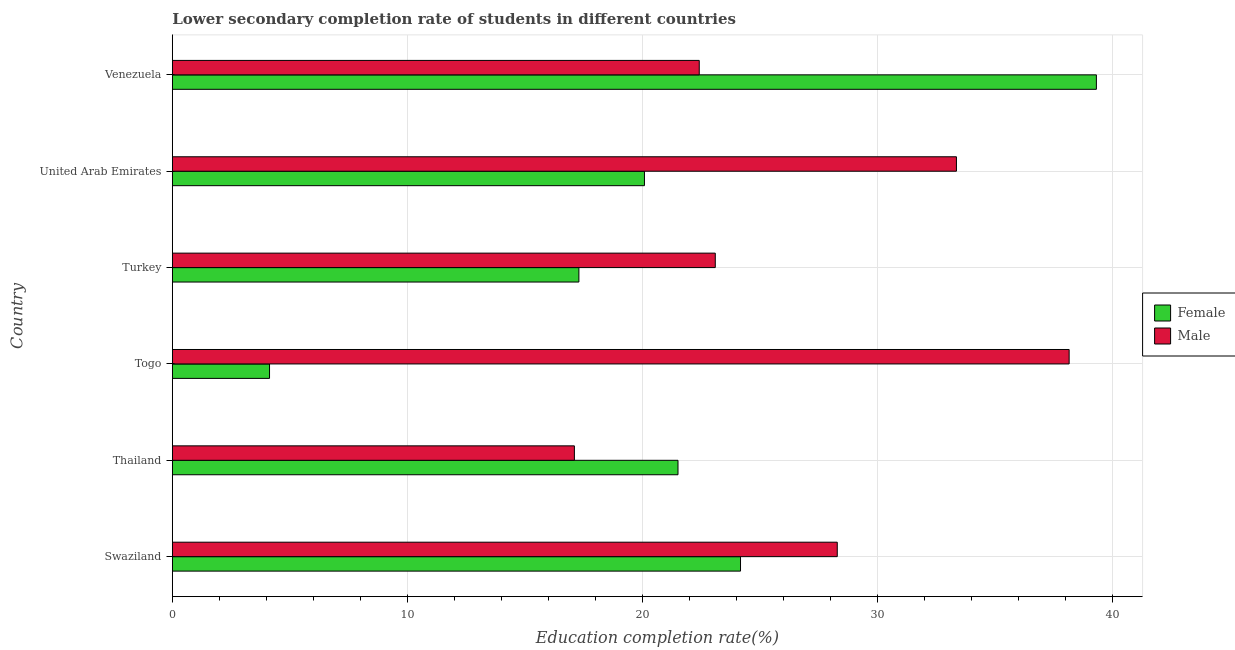How many bars are there on the 2nd tick from the bottom?
Your answer should be very brief. 2. What is the label of the 2nd group of bars from the top?
Offer a very short reply. United Arab Emirates. What is the education completion rate of female students in Togo?
Offer a terse response. 4.13. Across all countries, what is the maximum education completion rate of female students?
Offer a very short reply. 39.31. Across all countries, what is the minimum education completion rate of female students?
Ensure brevity in your answer.  4.13. In which country was the education completion rate of male students maximum?
Give a very brief answer. Togo. In which country was the education completion rate of female students minimum?
Provide a succinct answer. Togo. What is the total education completion rate of female students in the graph?
Keep it short and to the point. 126.52. What is the difference between the education completion rate of female students in Swaziland and that in Thailand?
Your answer should be very brief. 2.66. What is the difference between the education completion rate of male students in Venezuela and the education completion rate of female students in United Arab Emirates?
Give a very brief answer. 2.33. What is the average education completion rate of female students per country?
Your answer should be compact. 21.09. What is the difference between the education completion rate of male students and education completion rate of female students in Turkey?
Offer a terse response. 5.8. What is the ratio of the education completion rate of female students in Thailand to that in United Arab Emirates?
Give a very brief answer. 1.07. What is the difference between the highest and the second highest education completion rate of male students?
Provide a succinct answer. 4.79. What is the difference between the highest and the lowest education completion rate of female students?
Your response must be concise. 35.18. What does the 2nd bar from the top in Togo represents?
Provide a short and direct response. Female. Are all the bars in the graph horizontal?
Provide a short and direct response. Yes. How many countries are there in the graph?
Give a very brief answer. 6. Are the values on the major ticks of X-axis written in scientific E-notation?
Offer a very short reply. No. Does the graph contain any zero values?
Offer a terse response. No. Does the graph contain grids?
Make the answer very short. Yes. How are the legend labels stacked?
Your answer should be compact. Vertical. What is the title of the graph?
Provide a succinct answer. Lower secondary completion rate of students in different countries. Does "Broad money growth" appear as one of the legend labels in the graph?
Your response must be concise. No. What is the label or title of the X-axis?
Ensure brevity in your answer.  Education completion rate(%). What is the label or title of the Y-axis?
Give a very brief answer. Country. What is the Education completion rate(%) of Female in Swaziland?
Offer a terse response. 24.17. What is the Education completion rate(%) of Male in Swaziland?
Offer a terse response. 28.29. What is the Education completion rate(%) in Female in Thailand?
Your response must be concise. 21.51. What is the Education completion rate(%) in Male in Thailand?
Give a very brief answer. 17.11. What is the Education completion rate(%) of Female in Togo?
Ensure brevity in your answer.  4.13. What is the Education completion rate(%) of Male in Togo?
Your response must be concise. 38.16. What is the Education completion rate(%) in Female in Turkey?
Offer a terse response. 17.3. What is the Education completion rate(%) in Male in Turkey?
Offer a terse response. 23.1. What is the Education completion rate(%) in Female in United Arab Emirates?
Offer a terse response. 20.09. What is the Education completion rate(%) of Male in United Arab Emirates?
Ensure brevity in your answer.  33.36. What is the Education completion rate(%) in Female in Venezuela?
Offer a very short reply. 39.31. What is the Education completion rate(%) in Male in Venezuela?
Provide a succinct answer. 22.42. Across all countries, what is the maximum Education completion rate(%) in Female?
Give a very brief answer. 39.31. Across all countries, what is the maximum Education completion rate(%) of Male?
Offer a very short reply. 38.16. Across all countries, what is the minimum Education completion rate(%) of Female?
Make the answer very short. 4.13. Across all countries, what is the minimum Education completion rate(%) in Male?
Provide a short and direct response. 17.11. What is the total Education completion rate(%) in Female in the graph?
Your answer should be compact. 126.52. What is the total Education completion rate(%) of Male in the graph?
Offer a terse response. 162.43. What is the difference between the Education completion rate(%) of Female in Swaziland and that in Thailand?
Offer a very short reply. 2.66. What is the difference between the Education completion rate(%) in Male in Swaziland and that in Thailand?
Make the answer very short. 11.18. What is the difference between the Education completion rate(%) of Female in Swaziland and that in Togo?
Provide a succinct answer. 20.04. What is the difference between the Education completion rate(%) of Male in Swaziland and that in Togo?
Give a very brief answer. -9.87. What is the difference between the Education completion rate(%) of Female in Swaziland and that in Turkey?
Make the answer very short. 6.88. What is the difference between the Education completion rate(%) of Male in Swaziland and that in Turkey?
Offer a very short reply. 5.19. What is the difference between the Education completion rate(%) in Female in Swaziland and that in United Arab Emirates?
Your answer should be very brief. 4.09. What is the difference between the Education completion rate(%) in Male in Swaziland and that in United Arab Emirates?
Provide a short and direct response. -5.07. What is the difference between the Education completion rate(%) of Female in Swaziland and that in Venezuela?
Your answer should be compact. -15.14. What is the difference between the Education completion rate(%) in Male in Swaziland and that in Venezuela?
Offer a very short reply. 5.87. What is the difference between the Education completion rate(%) of Female in Thailand and that in Togo?
Give a very brief answer. 17.38. What is the difference between the Education completion rate(%) in Male in Thailand and that in Togo?
Ensure brevity in your answer.  -21.05. What is the difference between the Education completion rate(%) in Female in Thailand and that in Turkey?
Offer a very short reply. 4.22. What is the difference between the Education completion rate(%) in Male in Thailand and that in Turkey?
Your answer should be compact. -5.99. What is the difference between the Education completion rate(%) in Female in Thailand and that in United Arab Emirates?
Provide a succinct answer. 1.43. What is the difference between the Education completion rate(%) of Male in Thailand and that in United Arab Emirates?
Provide a short and direct response. -16.26. What is the difference between the Education completion rate(%) in Female in Thailand and that in Venezuela?
Keep it short and to the point. -17.8. What is the difference between the Education completion rate(%) in Male in Thailand and that in Venezuela?
Give a very brief answer. -5.31. What is the difference between the Education completion rate(%) of Female in Togo and that in Turkey?
Keep it short and to the point. -13.16. What is the difference between the Education completion rate(%) of Male in Togo and that in Turkey?
Keep it short and to the point. 15.06. What is the difference between the Education completion rate(%) of Female in Togo and that in United Arab Emirates?
Provide a succinct answer. -15.95. What is the difference between the Education completion rate(%) of Male in Togo and that in United Arab Emirates?
Provide a short and direct response. 4.79. What is the difference between the Education completion rate(%) of Female in Togo and that in Venezuela?
Give a very brief answer. -35.18. What is the difference between the Education completion rate(%) of Male in Togo and that in Venezuela?
Provide a short and direct response. 15.74. What is the difference between the Education completion rate(%) of Female in Turkey and that in United Arab Emirates?
Provide a short and direct response. -2.79. What is the difference between the Education completion rate(%) in Male in Turkey and that in United Arab Emirates?
Your answer should be very brief. -10.26. What is the difference between the Education completion rate(%) in Female in Turkey and that in Venezuela?
Provide a succinct answer. -22.02. What is the difference between the Education completion rate(%) of Male in Turkey and that in Venezuela?
Give a very brief answer. 0.68. What is the difference between the Education completion rate(%) of Female in United Arab Emirates and that in Venezuela?
Your response must be concise. -19.23. What is the difference between the Education completion rate(%) in Male in United Arab Emirates and that in Venezuela?
Your response must be concise. 10.94. What is the difference between the Education completion rate(%) of Female in Swaziland and the Education completion rate(%) of Male in Thailand?
Make the answer very short. 7.07. What is the difference between the Education completion rate(%) in Female in Swaziland and the Education completion rate(%) in Male in Togo?
Your answer should be compact. -13.98. What is the difference between the Education completion rate(%) of Female in Swaziland and the Education completion rate(%) of Male in Turkey?
Your answer should be compact. 1.07. What is the difference between the Education completion rate(%) in Female in Swaziland and the Education completion rate(%) in Male in United Arab Emirates?
Keep it short and to the point. -9.19. What is the difference between the Education completion rate(%) of Female in Swaziland and the Education completion rate(%) of Male in Venezuela?
Your answer should be very brief. 1.76. What is the difference between the Education completion rate(%) of Female in Thailand and the Education completion rate(%) of Male in Togo?
Keep it short and to the point. -16.64. What is the difference between the Education completion rate(%) in Female in Thailand and the Education completion rate(%) in Male in Turkey?
Offer a terse response. -1.59. What is the difference between the Education completion rate(%) of Female in Thailand and the Education completion rate(%) of Male in United Arab Emirates?
Your answer should be very brief. -11.85. What is the difference between the Education completion rate(%) of Female in Thailand and the Education completion rate(%) of Male in Venezuela?
Provide a succinct answer. -0.9. What is the difference between the Education completion rate(%) of Female in Togo and the Education completion rate(%) of Male in Turkey?
Give a very brief answer. -18.97. What is the difference between the Education completion rate(%) in Female in Togo and the Education completion rate(%) in Male in United Arab Emirates?
Offer a terse response. -29.23. What is the difference between the Education completion rate(%) of Female in Togo and the Education completion rate(%) of Male in Venezuela?
Your answer should be compact. -18.28. What is the difference between the Education completion rate(%) of Female in Turkey and the Education completion rate(%) of Male in United Arab Emirates?
Provide a short and direct response. -16.06. What is the difference between the Education completion rate(%) of Female in Turkey and the Education completion rate(%) of Male in Venezuela?
Your answer should be very brief. -5.12. What is the difference between the Education completion rate(%) in Female in United Arab Emirates and the Education completion rate(%) in Male in Venezuela?
Offer a terse response. -2.33. What is the average Education completion rate(%) in Female per country?
Give a very brief answer. 21.09. What is the average Education completion rate(%) in Male per country?
Your response must be concise. 27.07. What is the difference between the Education completion rate(%) of Female and Education completion rate(%) of Male in Swaziland?
Provide a succinct answer. -4.12. What is the difference between the Education completion rate(%) of Female and Education completion rate(%) of Male in Thailand?
Give a very brief answer. 4.41. What is the difference between the Education completion rate(%) of Female and Education completion rate(%) of Male in Togo?
Ensure brevity in your answer.  -34.02. What is the difference between the Education completion rate(%) in Female and Education completion rate(%) in Male in Turkey?
Make the answer very short. -5.8. What is the difference between the Education completion rate(%) of Female and Education completion rate(%) of Male in United Arab Emirates?
Make the answer very short. -13.27. What is the difference between the Education completion rate(%) of Female and Education completion rate(%) of Male in Venezuela?
Provide a succinct answer. 16.9. What is the ratio of the Education completion rate(%) of Female in Swaziland to that in Thailand?
Offer a terse response. 1.12. What is the ratio of the Education completion rate(%) in Male in Swaziland to that in Thailand?
Your response must be concise. 1.65. What is the ratio of the Education completion rate(%) of Female in Swaziland to that in Togo?
Ensure brevity in your answer.  5.85. What is the ratio of the Education completion rate(%) of Male in Swaziland to that in Togo?
Provide a succinct answer. 0.74. What is the ratio of the Education completion rate(%) in Female in Swaziland to that in Turkey?
Provide a succinct answer. 1.4. What is the ratio of the Education completion rate(%) in Male in Swaziland to that in Turkey?
Offer a very short reply. 1.22. What is the ratio of the Education completion rate(%) in Female in Swaziland to that in United Arab Emirates?
Your answer should be compact. 1.2. What is the ratio of the Education completion rate(%) of Male in Swaziland to that in United Arab Emirates?
Make the answer very short. 0.85. What is the ratio of the Education completion rate(%) of Female in Swaziland to that in Venezuela?
Your response must be concise. 0.61. What is the ratio of the Education completion rate(%) in Male in Swaziland to that in Venezuela?
Ensure brevity in your answer.  1.26. What is the ratio of the Education completion rate(%) of Female in Thailand to that in Togo?
Keep it short and to the point. 5.2. What is the ratio of the Education completion rate(%) of Male in Thailand to that in Togo?
Offer a terse response. 0.45. What is the ratio of the Education completion rate(%) of Female in Thailand to that in Turkey?
Make the answer very short. 1.24. What is the ratio of the Education completion rate(%) in Male in Thailand to that in Turkey?
Keep it short and to the point. 0.74. What is the ratio of the Education completion rate(%) in Female in Thailand to that in United Arab Emirates?
Keep it short and to the point. 1.07. What is the ratio of the Education completion rate(%) of Male in Thailand to that in United Arab Emirates?
Your answer should be very brief. 0.51. What is the ratio of the Education completion rate(%) of Female in Thailand to that in Venezuela?
Make the answer very short. 0.55. What is the ratio of the Education completion rate(%) in Male in Thailand to that in Venezuela?
Ensure brevity in your answer.  0.76. What is the ratio of the Education completion rate(%) of Female in Togo to that in Turkey?
Offer a terse response. 0.24. What is the ratio of the Education completion rate(%) of Male in Togo to that in Turkey?
Ensure brevity in your answer.  1.65. What is the ratio of the Education completion rate(%) in Female in Togo to that in United Arab Emirates?
Offer a very short reply. 0.21. What is the ratio of the Education completion rate(%) in Male in Togo to that in United Arab Emirates?
Give a very brief answer. 1.14. What is the ratio of the Education completion rate(%) in Female in Togo to that in Venezuela?
Your answer should be compact. 0.11. What is the ratio of the Education completion rate(%) of Male in Togo to that in Venezuela?
Ensure brevity in your answer.  1.7. What is the ratio of the Education completion rate(%) in Female in Turkey to that in United Arab Emirates?
Offer a very short reply. 0.86. What is the ratio of the Education completion rate(%) in Male in Turkey to that in United Arab Emirates?
Ensure brevity in your answer.  0.69. What is the ratio of the Education completion rate(%) in Female in Turkey to that in Venezuela?
Give a very brief answer. 0.44. What is the ratio of the Education completion rate(%) in Male in Turkey to that in Venezuela?
Your answer should be compact. 1.03. What is the ratio of the Education completion rate(%) in Female in United Arab Emirates to that in Venezuela?
Your response must be concise. 0.51. What is the ratio of the Education completion rate(%) of Male in United Arab Emirates to that in Venezuela?
Your answer should be very brief. 1.49. What is the difference between the highest and the second highest Education completion rate(%) of Female?
Offer a very short reply. 15.14. What is the difference between the highest and the second highest Education completion rate(%) in Male?
Provide a succinct answer. 4.79. What is the difference between the highest and the lowest Education completion rate(%) of Female?
Provide a short and direct response. 35.18. What is the difference between the highest and the lowest Education completion rate(%) of Male?
Your response must be concise. 21.05. 